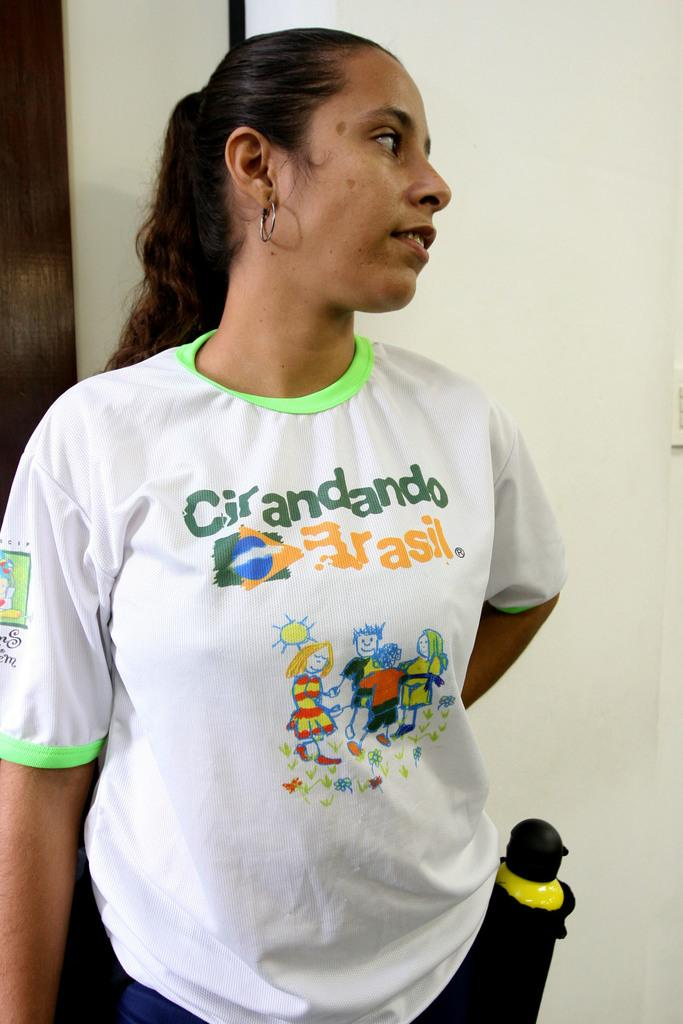What colors are present in the background of the picture? The background of the picture is white and brown in color. Who is in the picture? There is a woman in the picture. What is the woman wearing? The woman is wearing a t-shirt. What can be seen on the right side of the picture? There is an object on the right side of the picture. What type of toys can be seen on the canvas in the image? There is no canvas or toys present in the image. What kind of apparel is the woman wearing on her feet in the image? The provided facts do not mention the woman's footwear, so it cannot be determined from the image. 